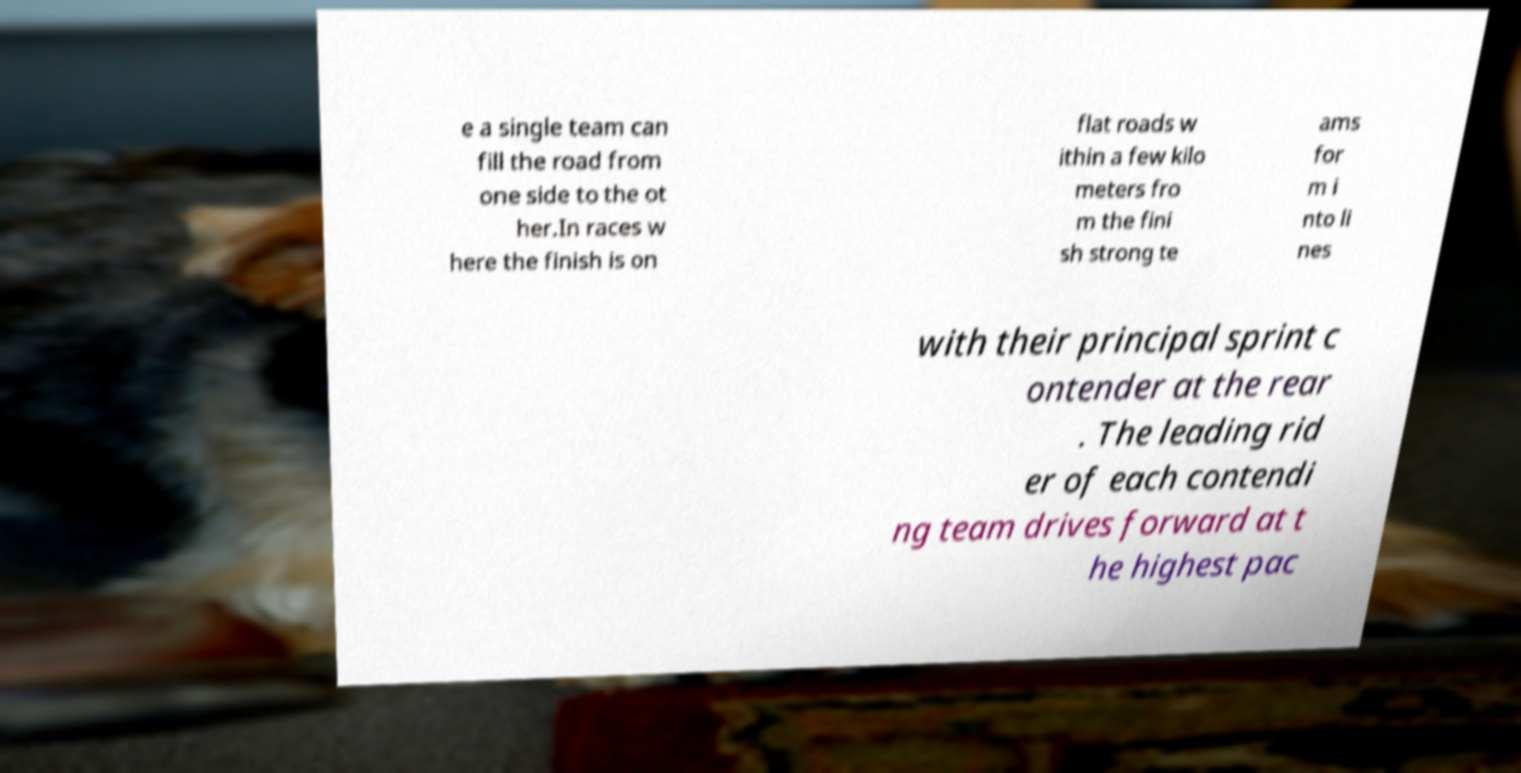Can you read and provide the text displayed in the image?This photo seems to have some interesting text. Can you extract and type it out for me? e a single team can fill the road from one side to the ot her.In races w here the finish is on flat roads w ithin a few kilo meters fro m the fini sh strong te ams for m i nto li nes with their principal sprint c ontender at the rear . The leading rid er of each contendi ng team drives forward at t he highest pac 